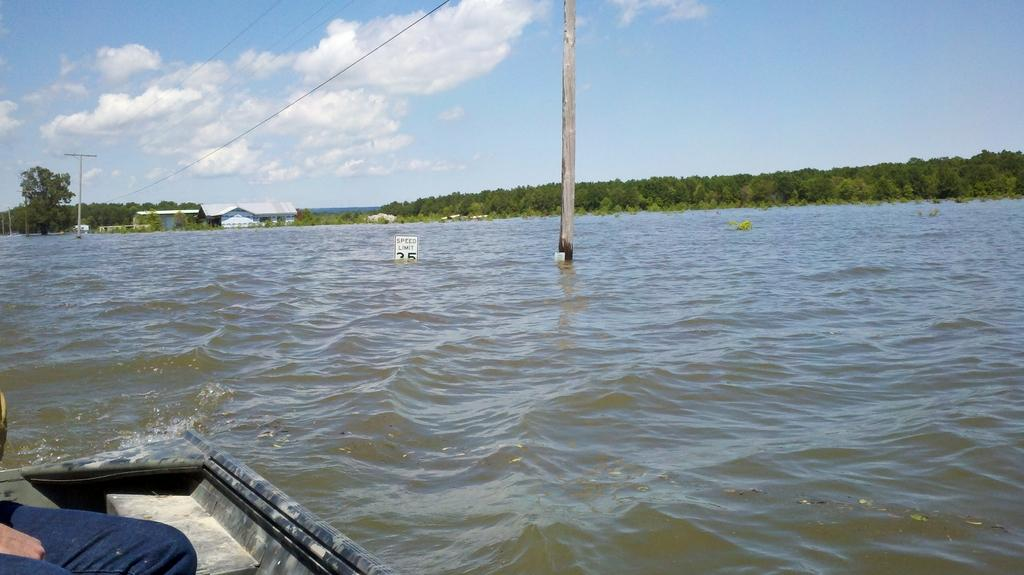What is the person in the image doing? There is a person sitting on a boat in the image. Where is the boat located? The boat is on the water. What can be seen in the background of the image? There are electric poles with cables, trees, houses, and the sky visible in the background. What type of leather is being used to construct the road in the image? There is no road present in the image, and therefore no leather can be associated with it. 